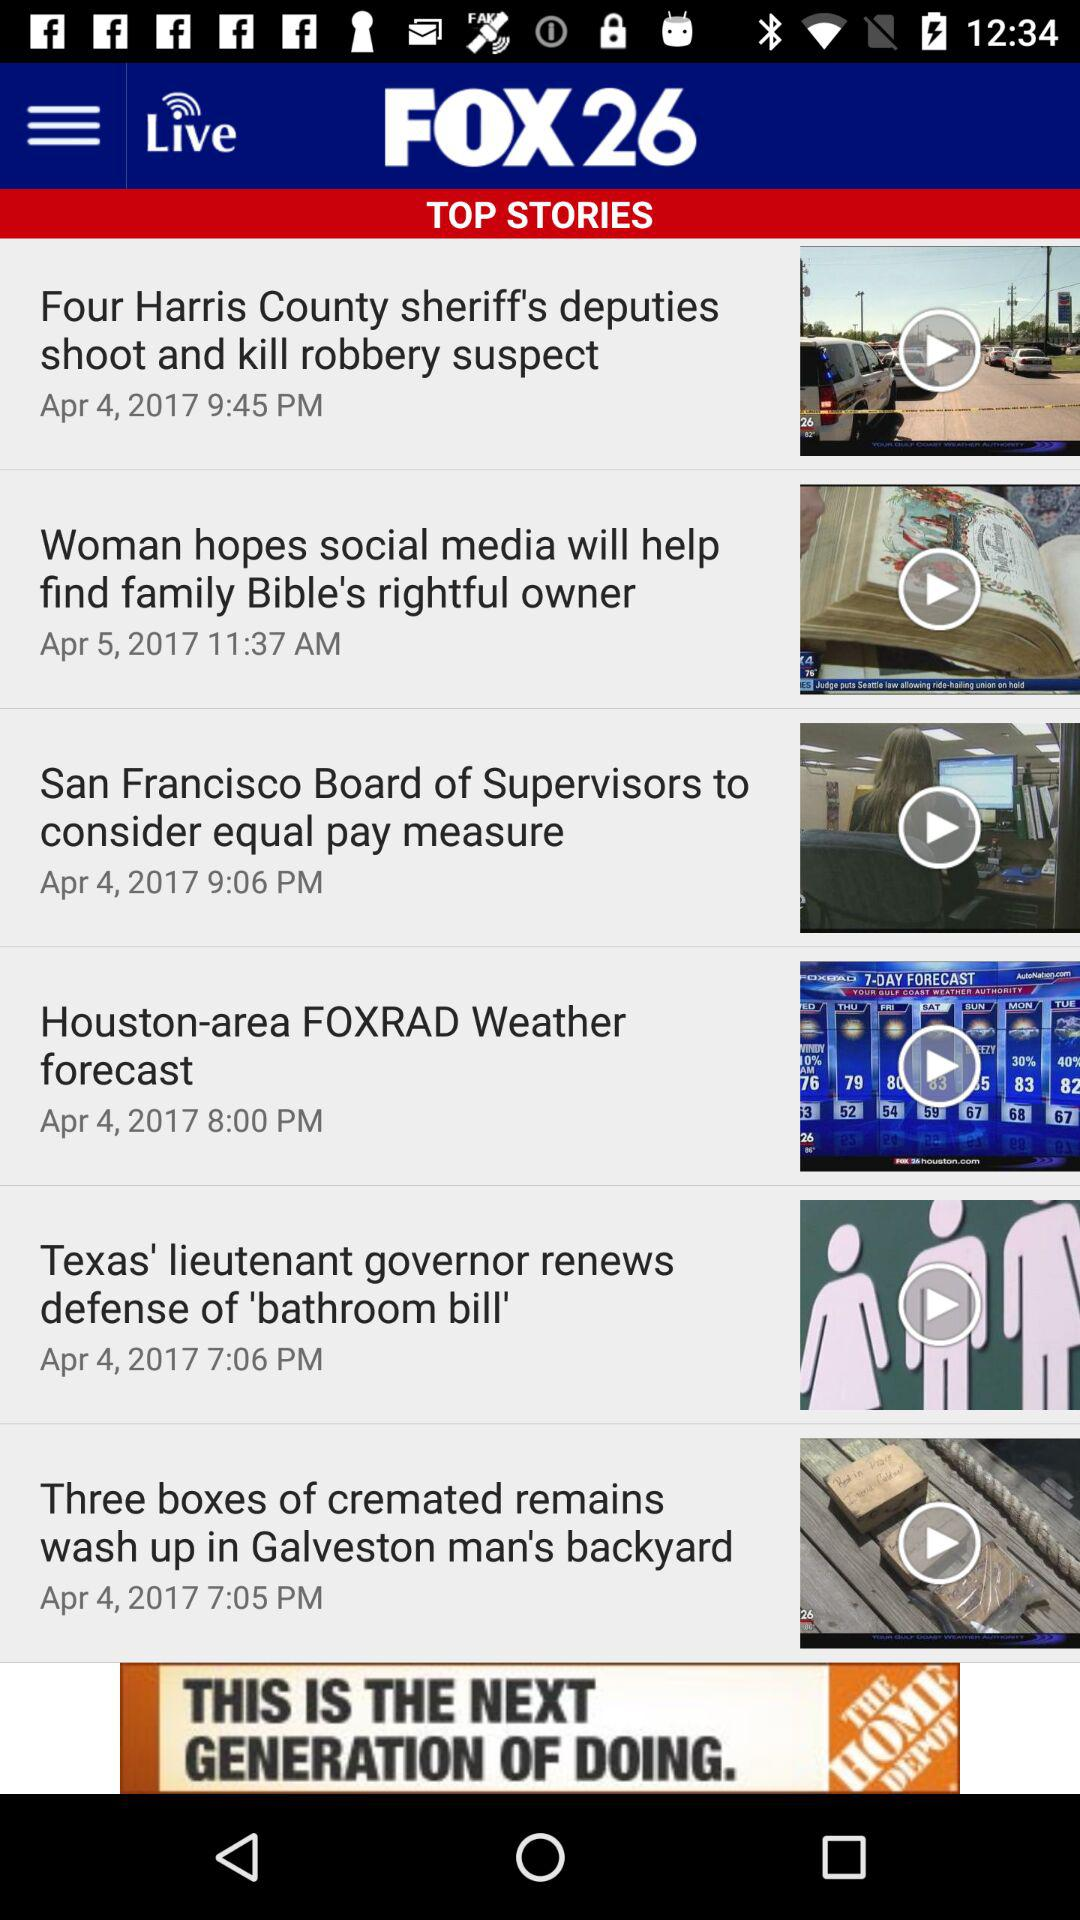What is the posted date of the "Houston-area FOXRAD Weather forecast"? The date of the post is April 4, 2017. 